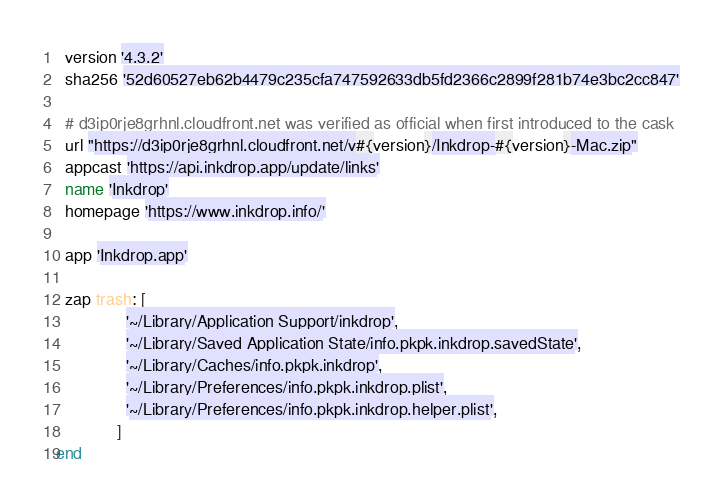Convert code to text. <code><loc_0><loc_0><loc_500><loc_500><_Ruby_>  version '4.3.2'
  sha256 '52d60527eb62b4479c235cfa747592633db5fd2366c2899f281b74e3bc2cc847'

  # d3ip0rje8grhnl.cloudfront.net was verified as official when first introduced to the cask
  url "https://d3ip0rje8grhnl.cloudfront.net/v#{version}/Inkdrop-#{version}-Mac.zip"
  appcast 'https://api.inkdrop.app/update/links'
  name 'Inkdrop'
  homepage 'https://www.inkdrop.info/'

  app 'Inkdrop.app'

  zap trash: [
               '~/Library/Application Support/inkdrop',
               '~/Library/Saved Application State/info.pkpk.inkdrop.savedState',
               '~/Library/Caches/info.pkpk.inkdrop',
               '~/Library/Preferences/info.pkpk.inkdrop.plist',
               '~/Library/Preferences/info.pkpk.inkdrop.helper.plist',
             ]
end
</code> 